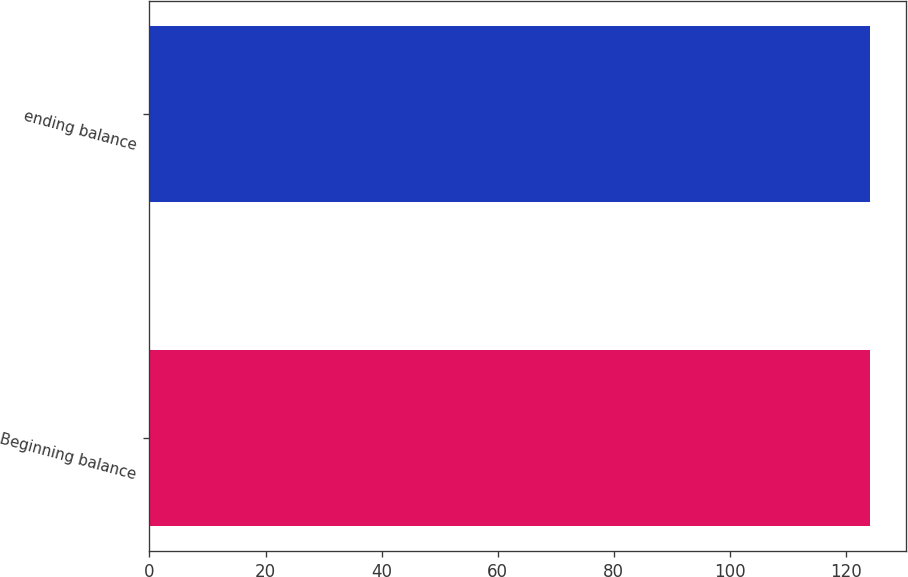<chart> <loc_0><loc_0><loc_500><loc_500><bar_chart><fcel>Beginning balance<fcel>ending balance<nl><fcel>124.1<fcel>124.2<nl></chart> 